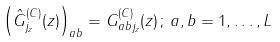<formula> <loc_0><loc_0><loc_500><loc_500>\left ( \hat { G } _ { j _ { z } } ^ { ( C ) } ( z ) \right ) _ { a b } = G _ { a b j _ { z } } ^ { ( C ) } ( z ) \, ; \, a , b = 1 , \dots , L</formula> 